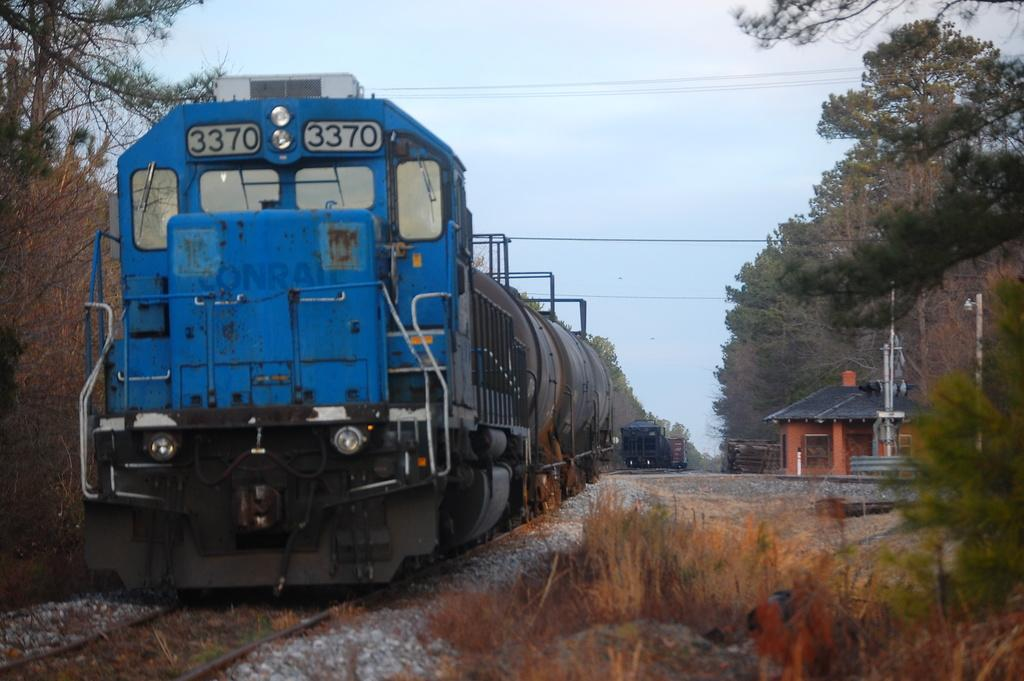How many trains can be seen in the image? There are two trains in the image. What type of vegetation is visible in the image? There is grass and trees visible in the image. Where is the house located in the image? The house is at the right side of the image. What type of structure is present near the house? There is an electrical pole in the image. Is there any quicksand visible in the image? No, there is no quicksand present in the image. Can you tell me the profession of the person standing near the house? There is no person visible in the image, so it is impossible to determine their profession. 